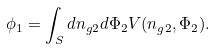<formula> <loc_0><loc_0><loc_500><loc_500>\phi _ { 1 } = \int _ { S } d n _ { g 2 } d \Phi _ { 2 } V ( n _ { g 2 } , \Phi _ { 2 } ) .</formula> 